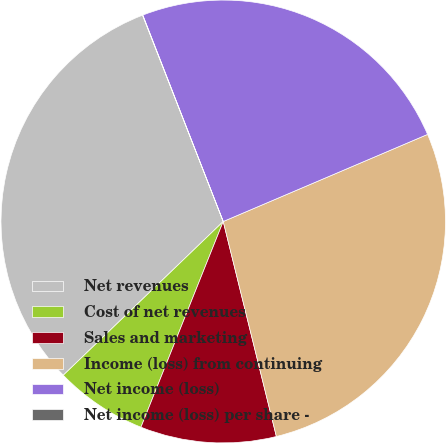<chart> <loc_0><loc_0><loc_500><loc_500><pie_chart><fcel>Net revenues<fcel>Cost of net revenues<fcel>Sales and marketing<fcel>Income (loss) from continuing<fcel>Net income (loss)<fcel>Net income (loss) per share -<nl><fcel>31.3%<fcel>6.75%<fcel>9.88%<fcel>27.59%<fcel>24.46%<fcel>0.02%<nl></chart> 